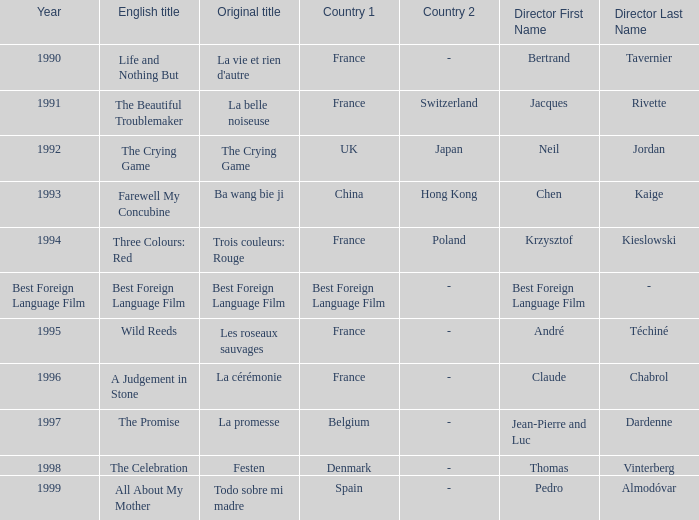Who is the Director of the Original title of The Crying Game? Neil Jordan. 